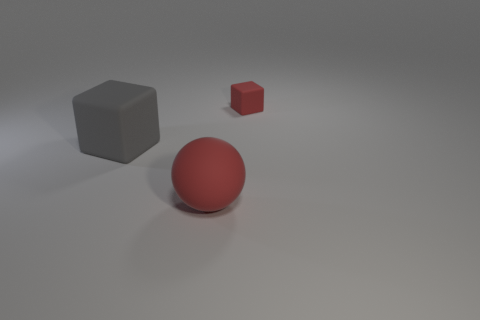Add 1 shiny cylinders. How many objects exist? 4 Subtract 2 cubes. How many cubes are left? 0 Subtract all gray cubes. How many cubes are left? 1 Subtract all blocks. How many objects are left? 1 Add 3 large brown cubes. How many large brown cubes exist? 3 Subtract 0 purple cylinders. How many objects are left? 3 Subtract all gray spheres. Subtract all green blocks. How many spheres are left? 1 Subtract all brown balls. How many gray blocks are left? 1 Subtract all large red rubber balls. Subtract all red rubber cubes. How many objects are left? 1 Add 2 small red blocks. How many small red blocks are left? 3 